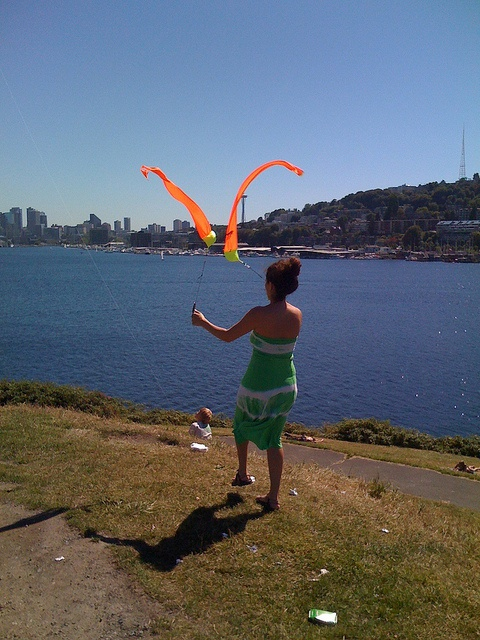Describe the objects in this image and their specific colors. I can see people in gray, black, maroon, and darkgreen tones, kite in gray, red, salmon, and lightpink tones, kite in gray, red, salmon, and darkgray tones, and people in gray, maroon, and black tones in this image. 